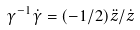Convert formula to latex. <formula><loc_0><loc_0><loc_500><loc_500>\gamma ^ { - 1 } \dot { \gamma } = ( - 1 / 2 ) \ddot { z } / \dot { z }</formula> 